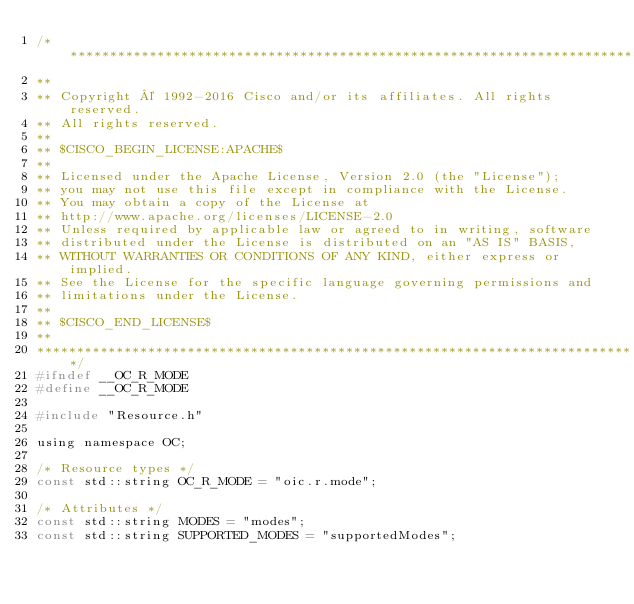Convert code to text. <code><loc_0><loc_0><loc_500><loc_500><_C_>/****************************************************************************
**
** Copyright © 1992-2016 Cisco and/or its affiliates. All rights reserved.
** All rights reserved.
**
** $CISCO_BEGIN_LICENSE:APACHE$
**
** Licensed under the Apache License, Version 2.0 (the "License");
** you may not use this file except in compliance with the License.
** You may obtain a copy of the License at
** http://www.apache.org/licenses/LICENSE-2.0
** Unless required by applicable law or agreed to in writing, software
** distributed under the License is distributed on an "AS IS" BASIS,
** WITHOUT WARRANTIES OR CONDITIONS OF ANY KIND, either express or implied.
** See the License for the specific language governing permissions and
** limitations under the License.
**
** $CISCO_END_LICENSE$
**
****************************************************************************/
#ifndef __OC_R_MODE
#define __OC_R_MODE

#include "Resource.h"

using namespace OC;

/* Resource types */
const std::string OC_R_MODE = "oic.r.mode";

/* Attributes */
const std::string MODES = "modes";
const std::string SUPPORTED_MODES = "supportedModes";

</code> 